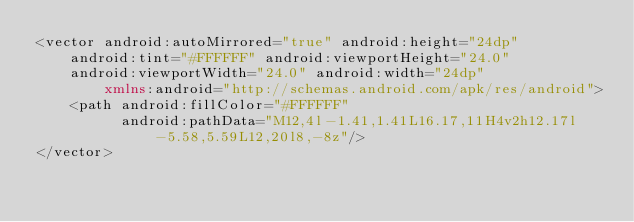Convert code to text. <code><loc_0><loc_0><loc_500><loc_500><_XML_><vector android:autoMirrored="true" android:height="24dp"
    android:tint="#FFFFFF" android:viewportHeight="24.0"
    android:viewportWidth="24.0" android:width="24dp"
        xmlns:android="http://schemas.android.com/apk/res/android">
    <path android:fillColor="#FFFFFF"
          android:pathData="M12,4l-1.41,1.41L16.17,11H4v2h12.17l-5.58,5.59L12,20l8,-8z"/>
</vector>
</code> 